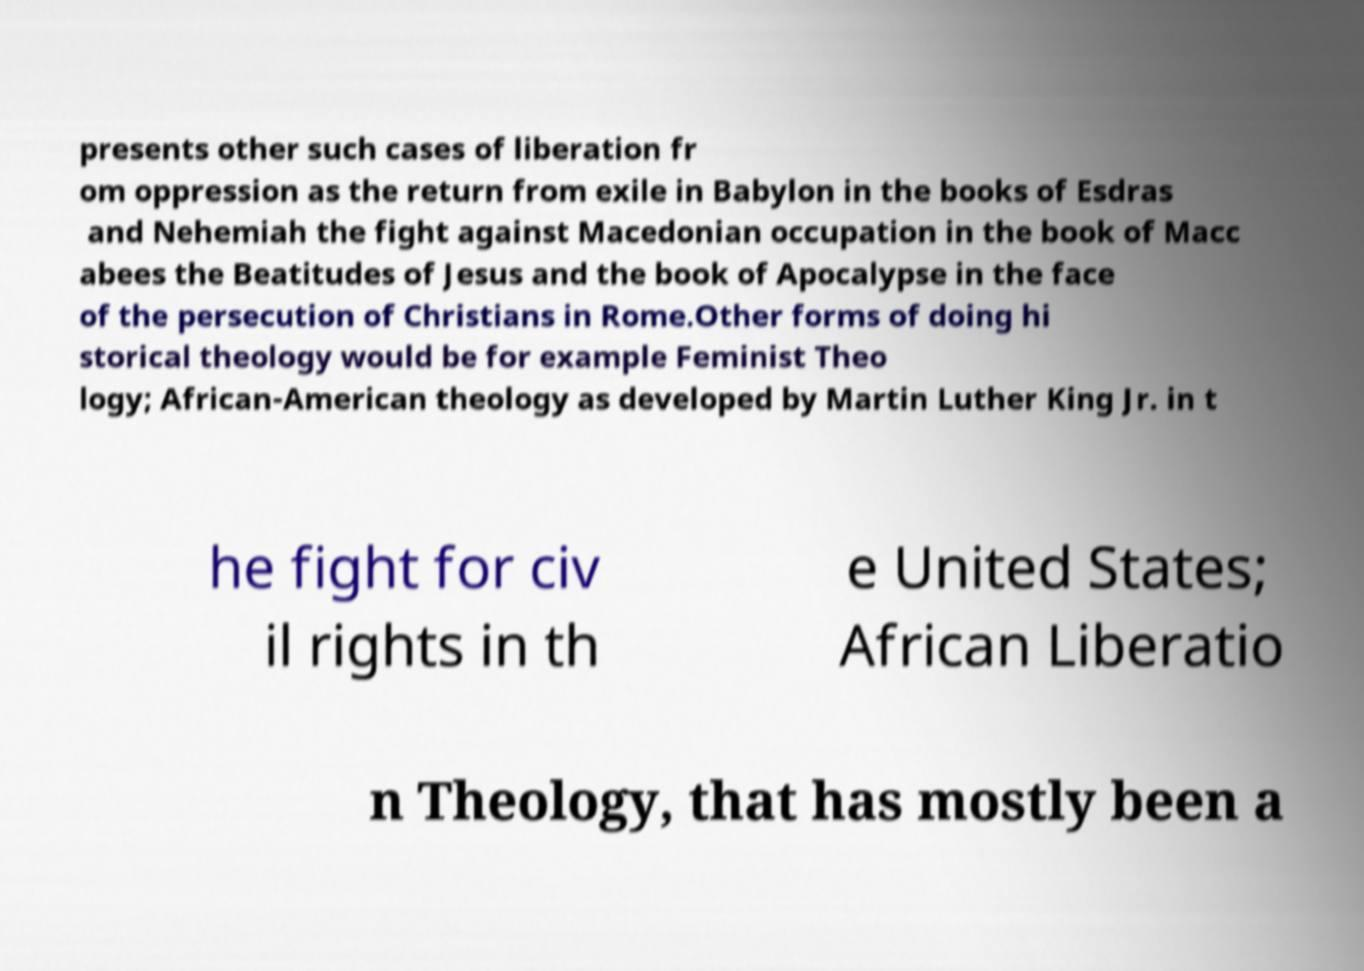For documentation purposes, I need the text within this image transcribed. Could you provide that? presents other such cases of liberation fr om oppression as the return from exile in Babylon in the books of Esdras and Nehemiah the fight against Macedonian occupation in the book of Macc abees the Beatitudes of Jesus and the book of Apocalypse in the face of the persecution of Christians in Rome.Other forms of doing hi storical theology would be for example Feminist Theo logy; African-American theology as developed by Martin Luther King Jr. in t he fight for civ il rights in th e United States; African Liberatio n Theology, that has mostly been a 